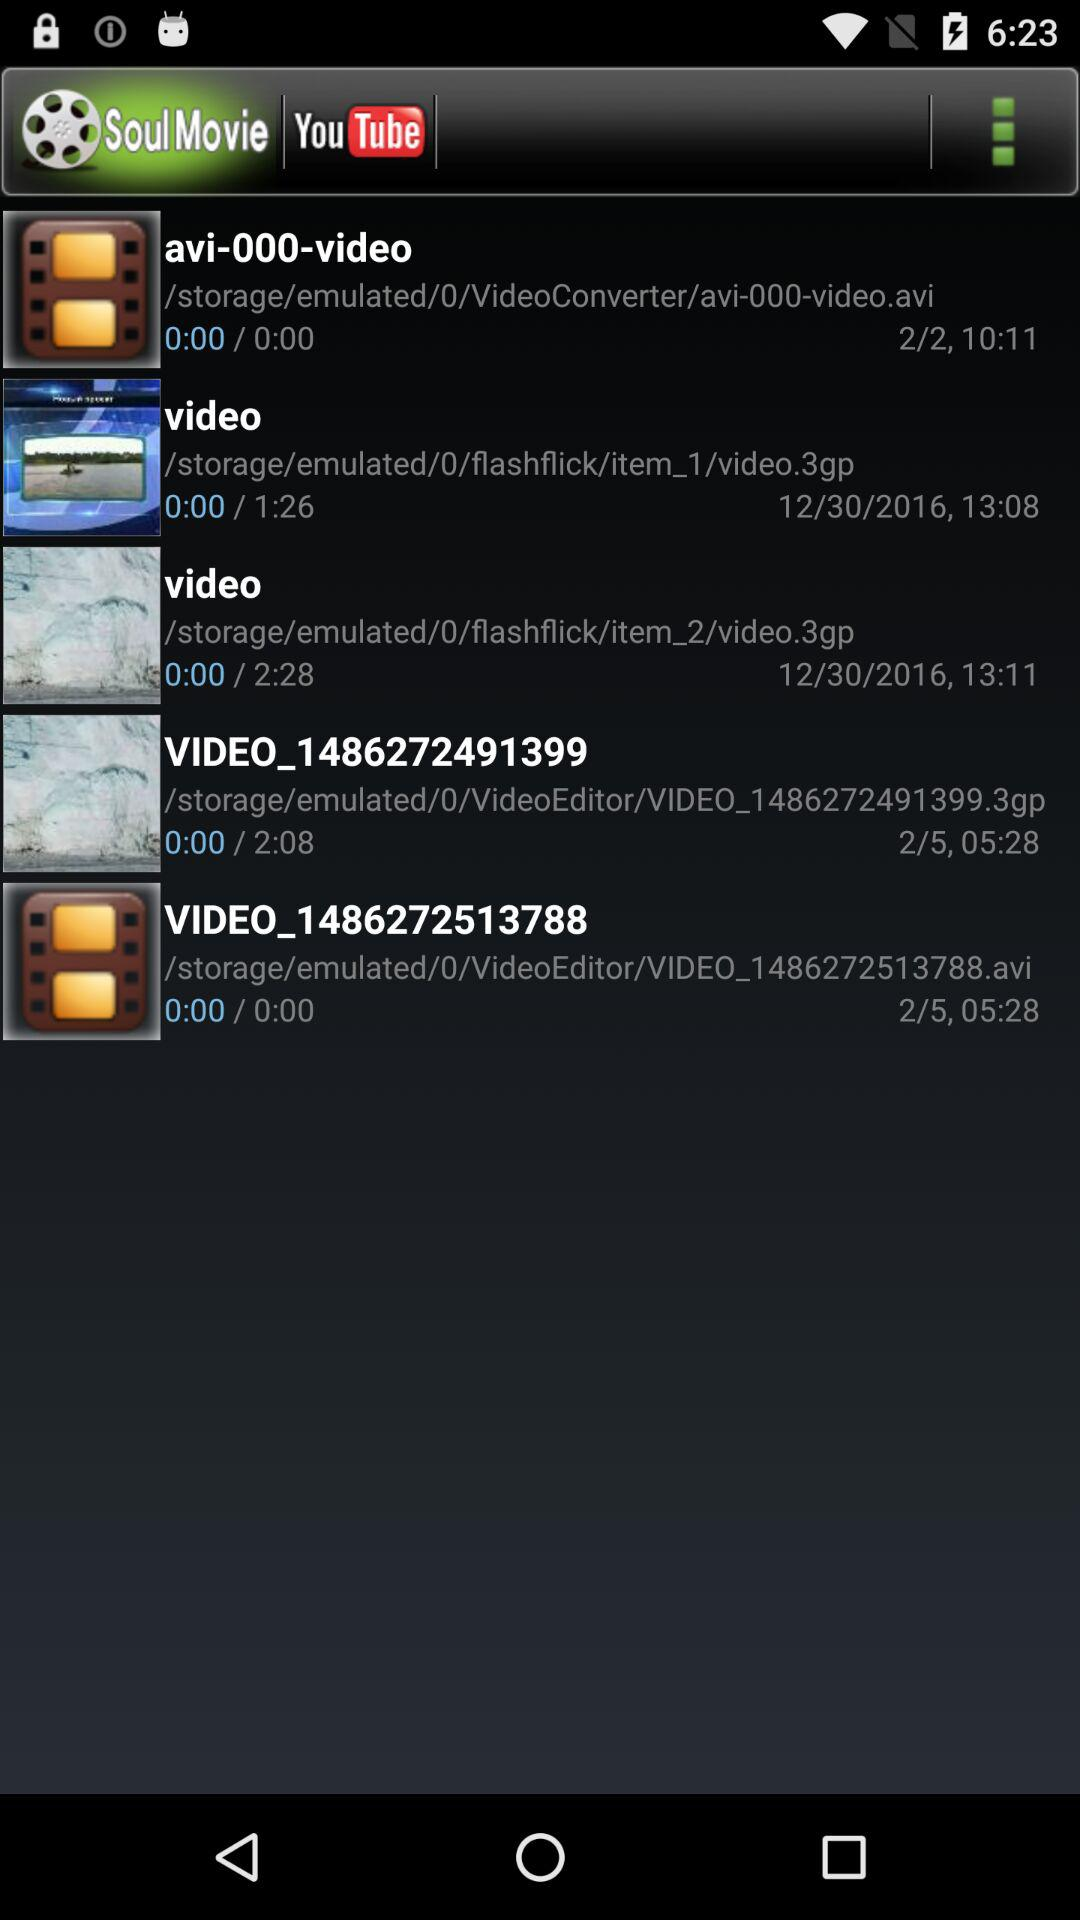What date is shown for "VIDEO_1486272513788"? The date is February 5. 